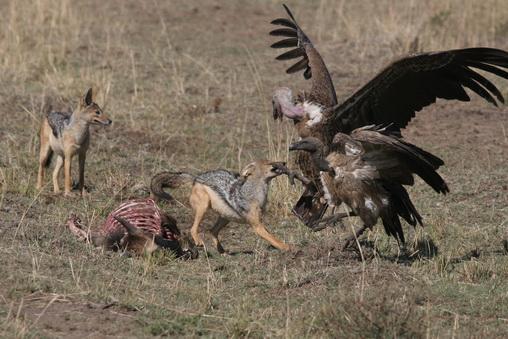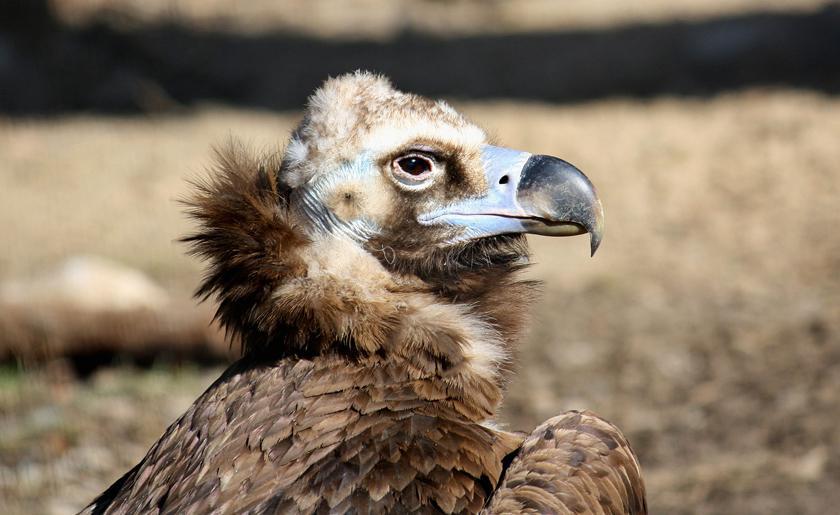The first image is the image on the left, the second image is the image on the right. For the images shown, is this caption "In at least one image there is a closeup of a lone vultures face" true? Answer yes or no. Yes. 